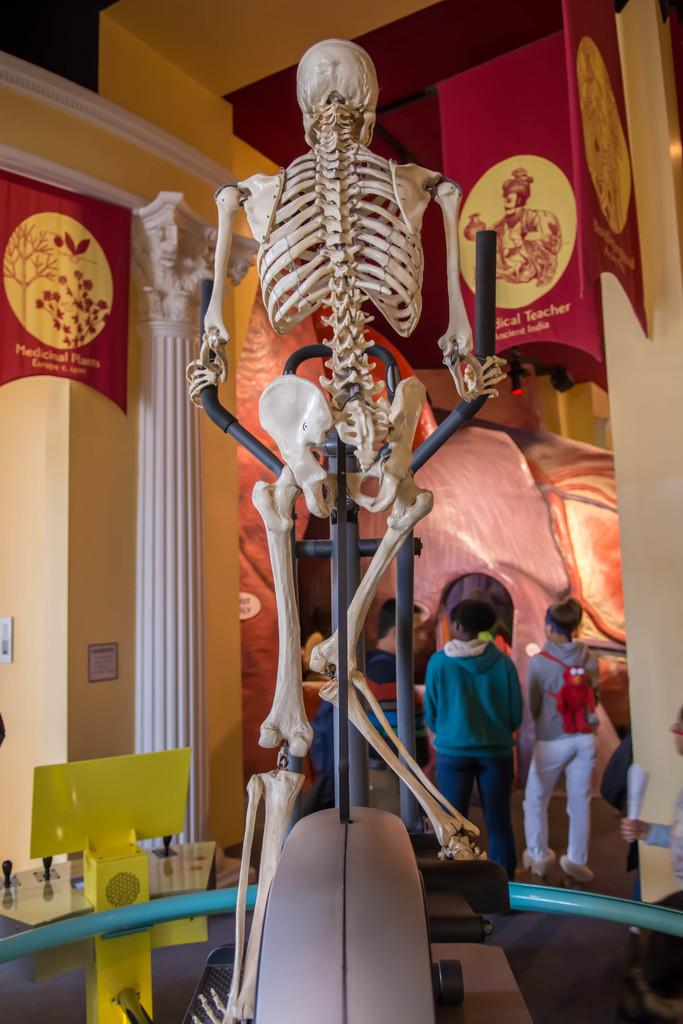What is placed on a stand in the image? There is a skeleton placed on a stand in the image. What can be seen in the background of the image? Walls, advertisement boards, and persons standing on the floor are visible in the background of the image. What type of education can be seen being provided in the image? There is no indication of education being provided in the image; it features a skeleton on a stand and various elements in the background. 